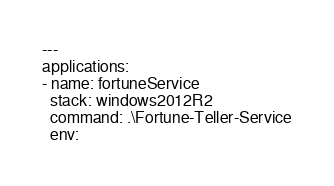<code> <loc_0><loc_0><loc_500><loc_500><_YAML_>---
applications:
- name: fortuneService
  stack: windows2012R2
  command: .\Fortune-Teller-Service
  env:</code> 